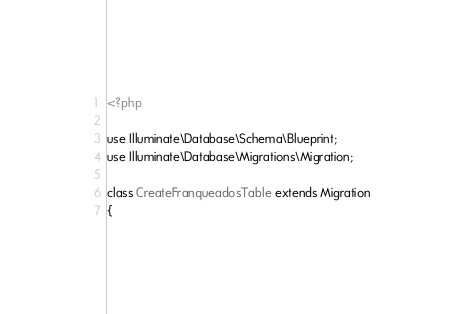<code> <loc_0><loc_0><loc_500><loc_500><_PHP_><?php

use Illuminate\Database\Schema\Blueprint;
use Illuminate\Database\Migrations\Migration;

class CreateFranqueadosTable extends Migration
{</code> 